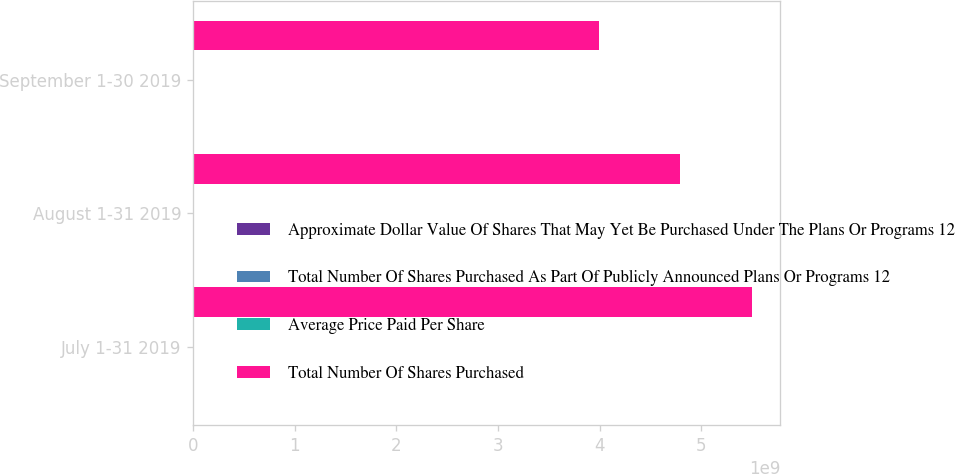Convert chart. <chart><loc_0><loc_0><loc_500><loc_500><stacked_bar_chart><ecel><fcel>July 1-31 2019<fcel>August 1-31 2019<fcel>September 1-30 2019<nl><fcel>Approximate Dollar Value Of Shares That May Yet Be Purchased Under The Plans Or Programs 12<fcel>3.6801e+06<fcel>4.0648e+06<fcel>4.4795e+06<nl><fcel>Total Number Of Shares Purchased As Part Of Publicly Announced Plans Or Programs 12<fcel>179.32<fcel>176.17<fcel>176.61<nl><fcel>Average Price Paid Per Share<fcel>3.6801e+06<fcel>4.0648e+06<fcel>4.4795e+06<nl><fcel>Total Number Of Shares Purchased<fcel>5.50243e+09<fcel>4.78627e+09<fcel>3.99505e+09<nl></chart> 